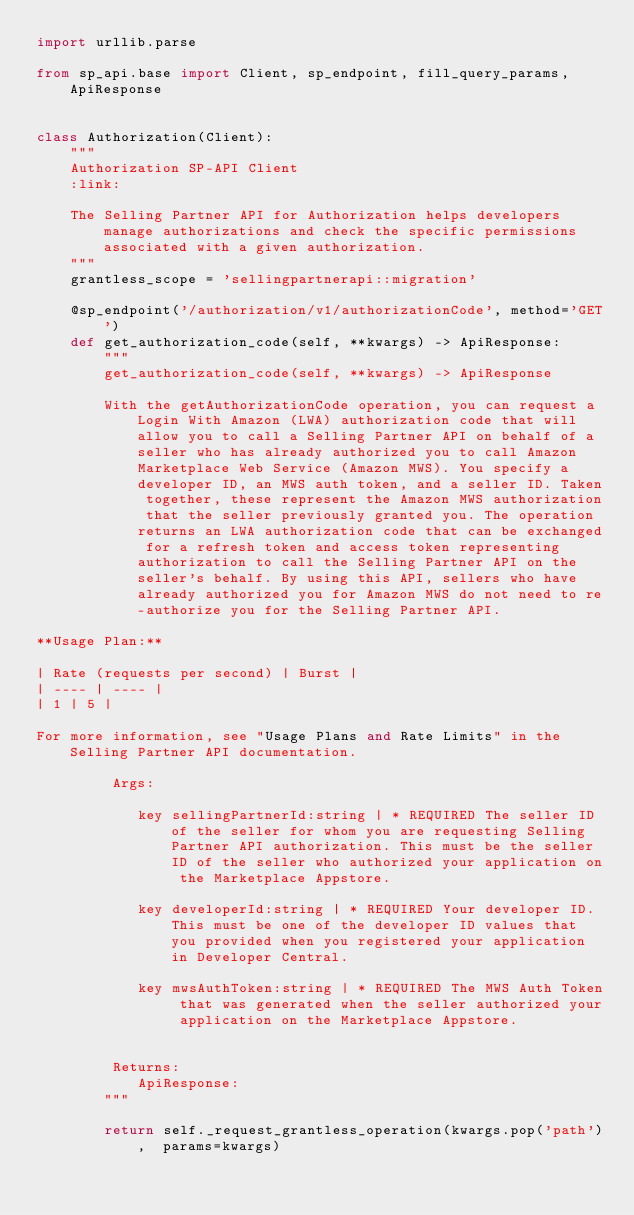Convert code to text. <code><loc_0><loc_0><loc_500><loc_500><_Python_>import urllib.parse

from sp_api.base import Client, sp_endpoint, fill_query_params, ApiResponse


class Authorization(Client):
    """
    Authorization SP-API Client
    :link: 

    The Selling Partner API for Authorization helps developers manage authorizations and check the specific permissions associated with a given authorization.
    """
    grantless_scope = 'sellingpartnerapi::migration'

    @sp_endpoint('/authorization/v1/authorizationCode', method='GET')
    def get_authorization_code(self, **kwargs) -> ApiResponse:
        """
        get_authorization_code(self, **kwargs) -> ApiResponse

        With the getAuthorizationCode operation, you can request a Login With Amazon (LWA) authorization code that will allow you to call a Selling Partner API on behalf of a seller who has already authorized you to call Amazon Marketplace Web Service (Amazon MWS). You specify a developer ID, an MWS auth token, and a seller ID. Taken together, these represent the Amazon MWS authorization that the seller previously granted you. The operation returns an LWA authorization code that can be exchanged for a refresh token and access token representing authorization to call the Selling Partner API on the seller's behalf. By using this API, sellers who have already authorized you for Amazon MWS do not need to re-authorize you for the Selling Partner API.

**Usage Plan:**

| Rate (requests per second) | Burst |
| ---- | ---- |
| 1 | 5 |

For more information, see "Usage Plans and Rate Limits" in the Selling Partner API documentation.

         Args:
        
            key sellingPartnerId:string | * REQUIRED The seller ID of the seller for whom you are requesting Selling Partner API authorization. This must be the seller ID of the seller who authorized your application on the Marketplace Appstore.
        
            key developerId:string | * REQUIRED Your developer ID. This must be one of the developer ID values that you provided when you registered your application in Developer Central.
        
            key mwsAuthToken:string | * REQUIRED The MWS Auth Token that was generated when the seller authorized your application on the Marketplace Appstore.
        

         Returns:
            ApiResponse:
        """
    
        return self._request_grantless_operation(kwargs.pop('path'),  params=kwargs)

</code> 